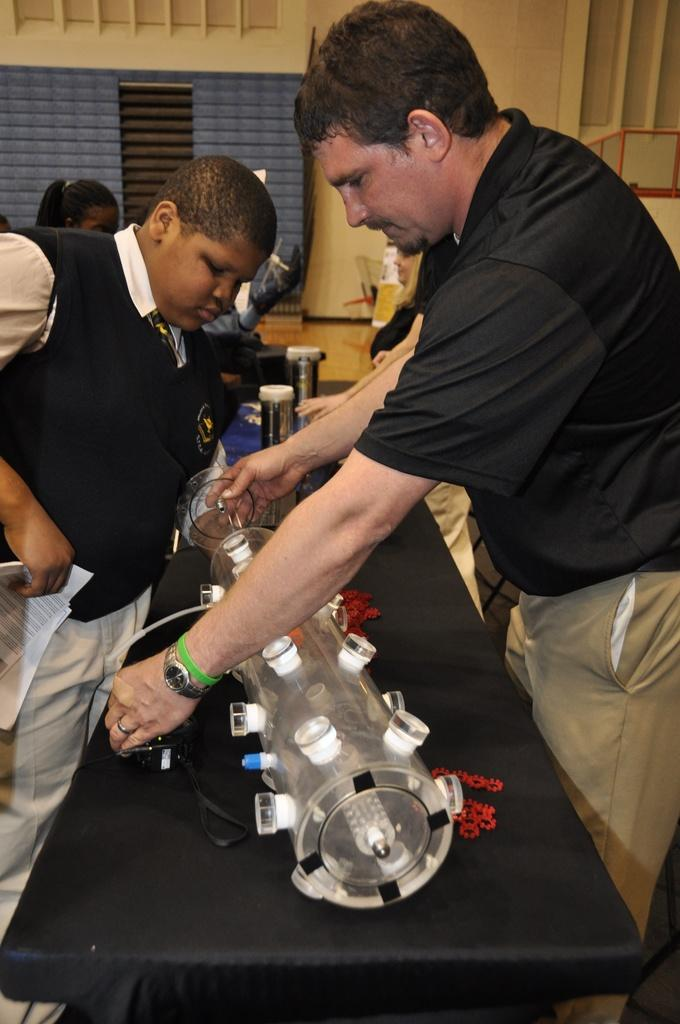How many people are in the image? There is a group of people in the image. Can you describe any objects present in the image? Unfortunately, the provided facts do not specify any objects present in the image. What is the tendency of the girl in the image? There is no mention of a girl in the provided facts, so we cannot answer this question. 